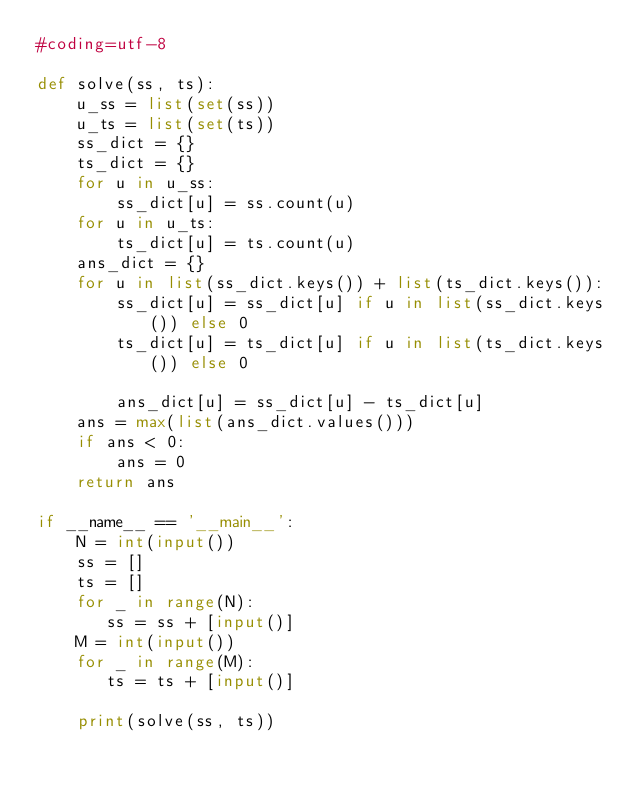Convert code to text. <code><loc_0><loc_0><loc_500><loc_500><_Python_>#coding=utf-8

def solve(ss, ts):
    u_ss = list(set(ss))
    u_ts = list(set(ts))
    ss_dict = {}
    ts_dict = {}
    for u in u_ss:
        ss_dict[u] = ss.count(u)
    for u in u_ts:
        ts_dict[u] = ts.count(u)
    ans_dict = {}
    for u in list(ss_dict.keys()) + list(ts_dict.keys()):
        ss_dict[u] = ss_dict[u] if u in list(ss_dict.keys()) else 0
        ts_dict[u] = ts_dict[u] if u in list(ts_dict.keys()) else 0

        ans_dict[u] = ss_dict[u] - ts_dict[u]
    ans = max(list(ans_dict.values()))
    if ans < 0:
        ans = 0
    return ans

if __name__ == '__main__':
    N = int(input())
    ss = []
    ts = []
    for _ in range(N):
       ss = ss + [input()] 
    M = int(input())
    for _ in range(M):
       ts = ts + [input()] 

    print(solve(ss, ts))
</code> 